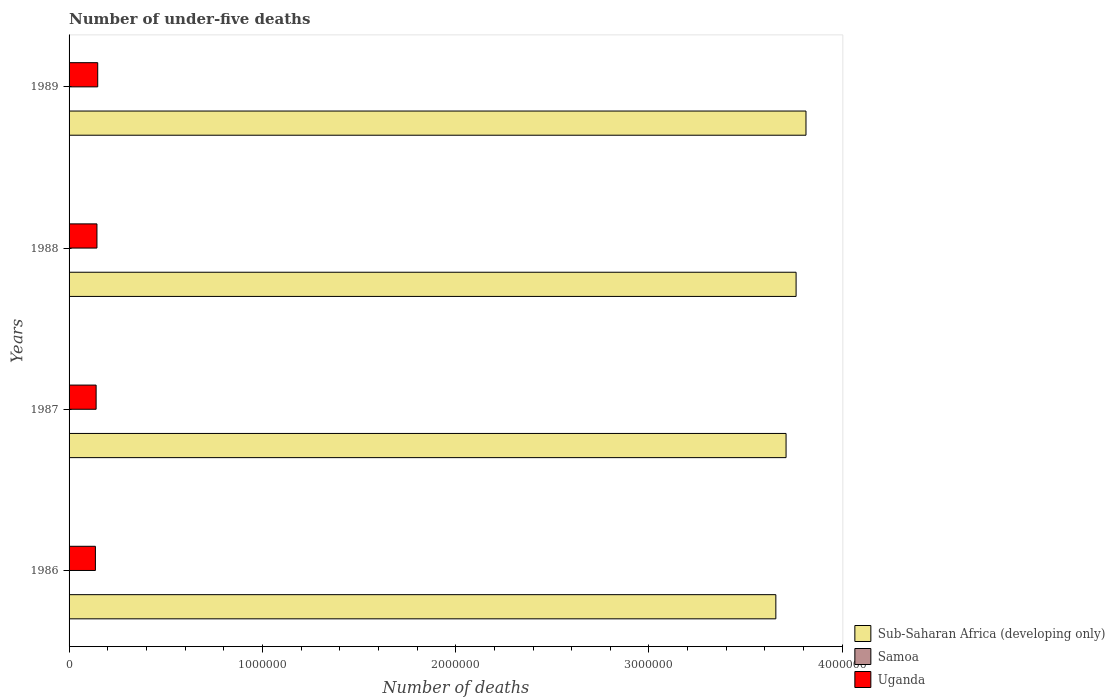How many different coloured bars are there?
Your answer should be very brief. 3. Are the number of bars per tick equal to the number of legend labels?
Ensure brevity in your answer.  Yes. How many bars are there on the 2nd tick from the top?
Your answer should be very brief. 3. How many bars are there on the 3rd tick from the bottom?
Your answer should be very brief. 3. What is the label of the 2nd group of bars from the top?
Make the answer very short. 1988. What is the number of under-five deaths in Samoa in 1987?
Give a very brief answer. 168. Across all years, what is the maximum number of under-five deaths in Sub-Saharan Africa (developing only)?
Provide a short and direct response. 3.81e+06. Across all years, what is the minimum number of under-five deaths in Uganda?
Give a very brief answer. 1.36e+05. What is the total number of under-five deaths in Samoa in the graph?
Ensure brevity in your answer.  663. What is the difference between the number of under-five deaths in Uganda in 1988 and that in 1989?
Your answer should be compact. -3960. What is the difference between the number of under-five deaths in Samoa in 1988 and the number of under-five deaths in Sub-Saharan Africa (developing only) in 1989?
Give a very brief answer. -3.81e+06. What is the average number of under-five deaths in Samoa per year?
Offer a very short reply. 165.75. In the year 1986, what is the difference between the number of under-five deaths in Samoa and number of under-five deaths in Uganda?
Offer a very short reply. -1.36e+05. In how many years, is the number of under-five deaths in Uganda greater than 1400000 ?
Provide a short and direct response. 0. What is the ratio of the number of under-five deaths in Samoa in 1986 to that in 1987?
Offer a terse response. 1.05. What is the difference between the highest and the second highest number of under-five deaths in Sub-Saharan Africa (developing only)?
Ensure brevity in your answer.  5.12e+04. What is the difference between the highest and the lowest number of under-five deaths in Uganda?
Offer a terse response. 1.19e+04. Is the sum of the number of under-five deaths in Sub-Saharan Africa (developing only) in 1986 and 1987 greater than the maximum number of under-five deaths in Uganda across all years?
Ensure brevity in your answer.  Yes. What does the 1st bar from the top in 1988 represents?
Your answer should be very brief. Uganda. What does the 1st bar from the bottom in 1986 represents?
Provide a succinct answer. Sub-Saharan Africa (developing only). Is it the case that in every year, the sum of the number of under-five deaths in Samoa and number of under-five deaths in Uganda is greater than the number of under-five deaths in Sub-Saharan Africa (developing only)?
Provide a short and direct response. No. How many bars are there?
Keep it short and to the point. 12. Are all the bars in the graph horizontal?
Give a very brief answer. Yes. Are the values on the major ticks of X-axis written in scientific E-notation?
Provide a succinct answer. No. Where does the legend appear in the graph?
Provide a succinct answer. Bottom right. How many legend labels are there?
Give a very brief answer. 3. What is the title of the graph?
Offer a very short reply. Number of under-five deaths. What is the label or title of the X-axis?
Give a very brief answer. Number of deaths. What is the Number of deaths of Sub-Saharan Africa (developing only) in 1986?
Ensure brevity in your answer.  3.66e+06. What is the Number of deaths of Samoa in 1986?
Offer a very short reply. 176. What is the Number of deaths of Uganda in 1986?
Keep it short and to the point. 1.36e+05. What is the Number of deaths in Sub-Saharan Africa (developing only) in 1987?
Ensure brevity in your answer.  3.71e+06. What is the Number of deaths in Samoa in 1987?
Ensure brevity in your answer.  168. What is the Number of deaths in Uganda in 1987?
Provide a short and direct response. 1.40e+05. What is the Number of deaths of Sub-Saharan Africa (developing only) in 1988?
Ensure brevity in your answer.  3.76e+06. What is the Number of deaths of Samoa in 1988?
Offer a very short reply. 162. What is the Number of deaths in Uganda in 1988?
Provide a short and direct response. 1.44e+05. What is the Number of deaths in Sub-Saharan Africa (developing only) in 1989?
Offer a very short reply. 3.81e+06. What is the Number of deaths in Samoa in 1989?
Offer a terse response. 157. What is the Number of deaths in Uganda in 1989?
Make the answer very short. 1.48e+05. Across all years, what is the maximum Number of deaths in Sub-Saharan Africa (developing only)?
Provide a succinct answer. 3.81e+06. Across all years, what is the maximum Number of deaths in Samoa?
Give a very brief answer. 176. Across all years, what is the maximum Number of deaths of Uganda?
Offer a terse response. 1.48e+05. Across all years, what is the minimum Number of deaths of Sub-Saharan Africa (developing only)?
Offer a terse response. 3.66e+06. Across all years, what is the minimum Number of deaths of Samoa?
Make the answer very short. 157. Across all years, what is the minimum Number of deaths in Uganda?
Your response must be concise. 1.36e+05. What is the total Number of deaths of Sub-Saharan Africa (developing only) in the graph?
Offer a very short reply. 1.49e+07. What is the total Number of deaths in Samoa in the graph?
Provide a succinct answer. 663. What is the total Number of deaths in Uganda in the graph?
Your answer should be compact. 5.69e+05. What is the difference between the Number of deaths in Sub-Saharan Africa (developing only) in 1986 and that in 1987?
Keep it short and to the point. -5.29e+04. What is the difference between the Number of deaths of Uganda in 1986 and that in 1987?
Your answer should be compact. -3713. What is the difference between the Number of deaths of Sub-Saharan Africa (developing only) in 1986 and that in 1988?
Give a very brief answer. -1.05e+05. What is the difference between the Number of deaths in Samoa in 1986 and that in 1988?
Keep it short and to the point. 14. What is the difference between the Number of deaths of Uganda in 1986 and that in 1988?
Provide a succinct answer. -7969. What is the difference between the Number of deaths of Sub-Saharan Africa (developing only) in 1986 and that in 1989?
Your answer should be very brief. -1.56e+05. What is the difference between the Number of deaths of Uganda in 1986 and that in 1989?
Your response must be concise. -1.19e+04. What is the difference between the Number of deaths of Sub-Saharan Africa (developing only) in 1987 and that in 1988?
Offer a terse response. -5.18e+04. What is the difference between the Number of deaths of Samoa in 1987 and that in 1988?
Offer a terse response. 6. What is the difference between the Number of deaths of Uganda in 1987 and that in 1988?
Keep it short and to the point. -4256. What is the difference between the Number of deaths of Sub-Saharan Africa (developing only) in 1987 and that in 1989?
Your answer should be compact. -1.03e+05. What is the difference between the Number of deaths of Uganda in 1987 and that in 1989?
Offer a very short reply. -8216. What is the difference between the Number of deaths of Sub-Saharan Africa (developing only) in 1988 and that in 1989?
Offer a very short reply. -5.12e+04. What is the difference between the Number of deaths in Uganda in 1988 and that in 1989?
Ensure brevity in your answer.  -3960. What is the difference between the Number of deaths of Sub-Saharan Africa (developing only) in 1986 and the Number of deaths of Samoa in 1987?
Your answer should be very brief. 3.66e+06. What is the difference between the Number of deaths of Sub-Saharan Africa (developing only) in 1986 and the Number of deaths of Uganda in 1987?
Make the answer very short. 3.52e+06. What is the difference between the Number of deaths in Samoa in 1986 and the Number of deaths in Uganda in 1987?
Offer a very short reply. -1.40e+05. What is the difference between the Number of deaths of Sub-Saharan Africa (developing only) in 1986 and the Number of deaths of Samoa in 1988?
Your answer should be very brief. 3.66e+06. What is the difference between the Number of deaths in Sub-Saharan Africa (developing only) in 1986 and the Number of deaths in Uganda in 1988?
Offer a very short reply. 3.51e+06. What is the difference between the Number of deaths in Samoa in 1986 and the Number of deaths in Uganda in 1988?
Keep it short and to the point. -1.44e+05. What is the difference between the Number of deaths of Sub-Saharan Africa (developing only) in 1986 and the Number of deaths of Samoa in 1989?
Provide a succinct answer. 3.66e+06. What is the difference between the Number of deaths of Sub-Saharan Africa (developing only) in 1986 and the Number of deaths of Uganda in 1989?
Ensure brevity in your answer.  3.51e+06. What is the difference between the Number of deaths in Samoa in 1986 and the Number of deaths in Uganda in 1989?
Ensure brevity in your answer.  -1.48e+05. What is the difference between the Number of deaths in Sub-Saharan Africa (developing only) in 1987 and the Number of deaths in Samoa in 1988?
Offer a very short reply. 3.71e+06. What is the difference between the Number of deaths in Sub-Saharan Africa (developing only) in 1987 and the Number of deaths in Uganda in 1988?
Keep it short and to the point. 3.56e+06. What is the difference between the Number of deaths in Samoa in 1987 and the Number of deaths in Uganda in 1988?
Provide a short and direct response. -1.44e+05. What is the difference between the Number of deaths of Sub-Saharan Africa (developing only) in 1987 and the Number of deaths of Samoa in 1989?
Your answer should be compact. 3.71e+06. What is the difference between the Number of deaths of Sub-Saharan Africa (developing only) in 1987 and the Number of deaths of Uganda in 1989?
Give a very brief answer. 3.56e+06. What is the difference between the Number of deaths in Samoa in 1987 and the Number of deaths in Uganda in 1989?
Provide a short and direct response. -1.48e+05. What is the difference between the Number of deaths of Sub-Saharan Africa (developing only) in 1988 and the Number of deaths of Samoa in 1989?
Keep it short and to the point. 3.76e+06. What is the difference between the Number of deaths in Sub-Saharan Africa (developing only) in 1988 and the Number of deaths in Uganda in 1989?
Your answer should be very brief. 3.61e+06. What is the difference between the Number of deaths of Samoa in 1988 and the Number of deaths of Uganda in 1989?
Ensure brevity in your answer.  -1.48e+05. What is the average Number of deaths in Sub-Saharan Africa (developing only) per year?
Provide a succinct answer. 3.73e+06. What is the average Number of deaths of Samoa per year?
Provide a short and direct response. 165.75. What is the average Number of deaths in Uganda per year?
Give a very brief answer. 1.42e+05. In the year 1986, what is the difference between the Number of deaths of Sub-Saharan Africa (developing only) and Number of deaths of Samoa?
Your answer should be very brief. 3.66e+06. In the year 1986, what is the difference between the Number of deaths of Sub-Saharan Africa (developing only) and Number of deaths of Uganda?
Make the answer very short. 3.52e+06. In the year 1986, what is the difference between the Number of deaths in Samoa and Number of deaths in Uganda?
Make the answer very short. -1.36e+05. In the year 1987, what is the difference between the Number of deaths in Sub-Saharan Africa (developing only) and Number of deaths in Samoa?
Keep it short and to the point. 3.71e+06. In the year 1987, what is the difference between the Number of deaths in Sub-Saharan Africa (developing only) and Number of deaths in Uganda?
Offer a terse response. 3.57e+06. In the year 1987, what is the difference between the Number of deaths in Samoa and Number of deaths in Uganda?
Offer a very short reply. -1.40e+05. In the year 1988, what is the difference between the Number of deaths in Sub-Saharan Africa (developing only) and Number of deaths in Samoa?
Make the answer very short. 3.76e+06. In the year 1988, what is the difference between the Number of deaths in Sub-Saharan Africa (developing only) and Number of deaths in Uganda?
Provide a short and direct response. 3.62e+06. In the year 1988, what is the difference between the Number of deaths of Samoa and Number of deaths of Uganda?
Your response must be concise. -1.44e+05. In the year 1989, what is the difference between the Number of deaths in Sub-Saharan Africa (developing only) and Number of deaths in Samoa?
Make the answer very short. 3.81e+06. In the year 1989, what is the difference between the Number of deaths in Sub-Saharan Africa (developing only) and Number of deaths in Uganda?
Provide a succinct answer. 3.66e+06. In the year 1989, what is the difference between the Number of deaths in Samoa and Number of deaths in Uganda?
Your answer should be very brief. -1.48e+05. What is the ratio of the Number of deaths in Sub-Saharan Africa (developing only) in 1986 to that in 1987?
Offer a terse response. 0.99. What is the ratio of the Number of deaths of Samoa in 1986 to that in 1987?
Give a very brief answer. 1.05. What is the ratio of the Number of deaths of Uganda in 1986 to that in 1987?
Your answer should be compact. 0.97. What is the ratio of the Number of deaths in Sub-Saharan Africa (developing only) in 1986 to that in 1988?
Make the answer very short. 0.97. What is the ratio of the Number of deaths in Samoa in 1986 to that in 1988?
Your answer should be very brief. 1.09. What is the ratio of the Number of deaths in Uganda in 1986 to that in 1988?
Make the answer very short. 0.94. What is the ratio of the Number of deaths of Sub-Saharan Africa (developing only) in 1986 to that in 1989?
Offer a terse response. 0.96. What is the ratio of the Number of deaths of Samoa in 1986 to that in 1989?
Ensure brevity in your answer.  1.12. What is the ratio of the Number of deaths of Uganda in 1986 to that in 1989?
Provide a short and direct response. 0.92. What is the ratio of the Number of deaths of Sub-Saharan Africa (developing only) in 1987 to that in 1988?
Give a very brief answer. 0.99. What is the ratio of the Number of deaths in Samoa in 1987 to that in 1988?
Provide a short and direct response. 1.04. What is the ratio of the Number of deaths in Uganda in 1987 to that in 1988?
Your response must be concise. 0.97. What is the ratio of the Number of deaths in Samoa in 1987 to that in 1989?
Your answer should be very brief. 1.07. What is the ratio of the Number of deaths of Uganda in 1987 to that in 1989?
Offer a very short reply. 0.94. What is the ratio of the Number of deaths of Sub-Saharan Africa (developing only) in 1988 to that in 1989?
Keep it short and to the point. 0.99. What is the ratio of the Number of deaths in Samoa in 1988 to that in 1989?
Provide a short and direct response. 1.03. What is the ratio of the Number of deaths of Uganda in 1988 to that in 1989?
Provide a short and direct response. 0.97. What is the difference between the highest and the second highest Number of deaths of Sub-Saharan Africa (developing only)?
Give a very brief answer. 5.12e+04. What is the difference between the highest and the second highest Number of deaths in Uganda?
Offer a terse response. 3960. What is the difference between the highest and the lowest Number of deaths in Sub-Saharan Africa (developing only)?
Offer a terse response. 1.56e+05. What is the difference between the highest and the lowest Number of deaths of Samoa?
Keep it short and to the point. 19. What is the difference between the highest and the lowest Number of deaths of Uganda?
Keep it short and to the point. 1.19e+04. 